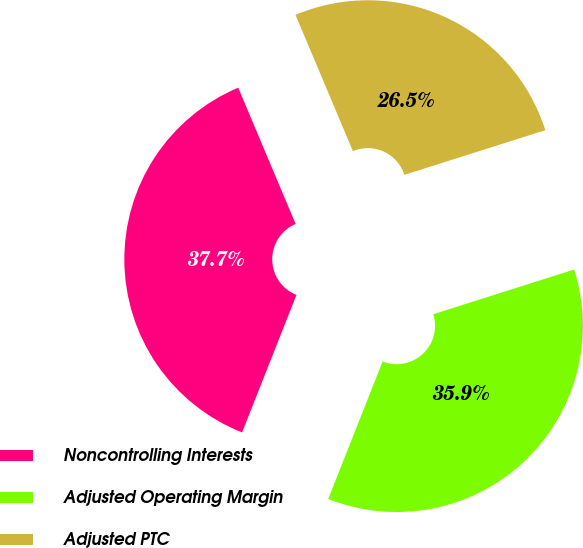Convert chart. <chart><loc_0><loc_0><loc_500><loc_500><pie_chart><fcel>Noncontrolling Interests<fcel>Adjusted Operating Margin<fcel>Adjusted PTC<nl><fcel>37.66%<fcel>35.88%<fcel>26.46%<nl></chart> 